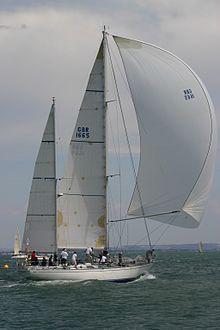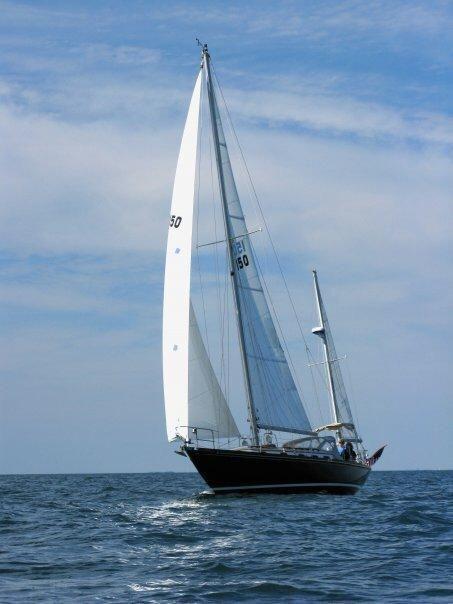The first image is the image on the left, the second image is the image on the right. Considering the images on both sides, is "The boat in the right image has exactly four sails." valid? Answer yes or no. No. 